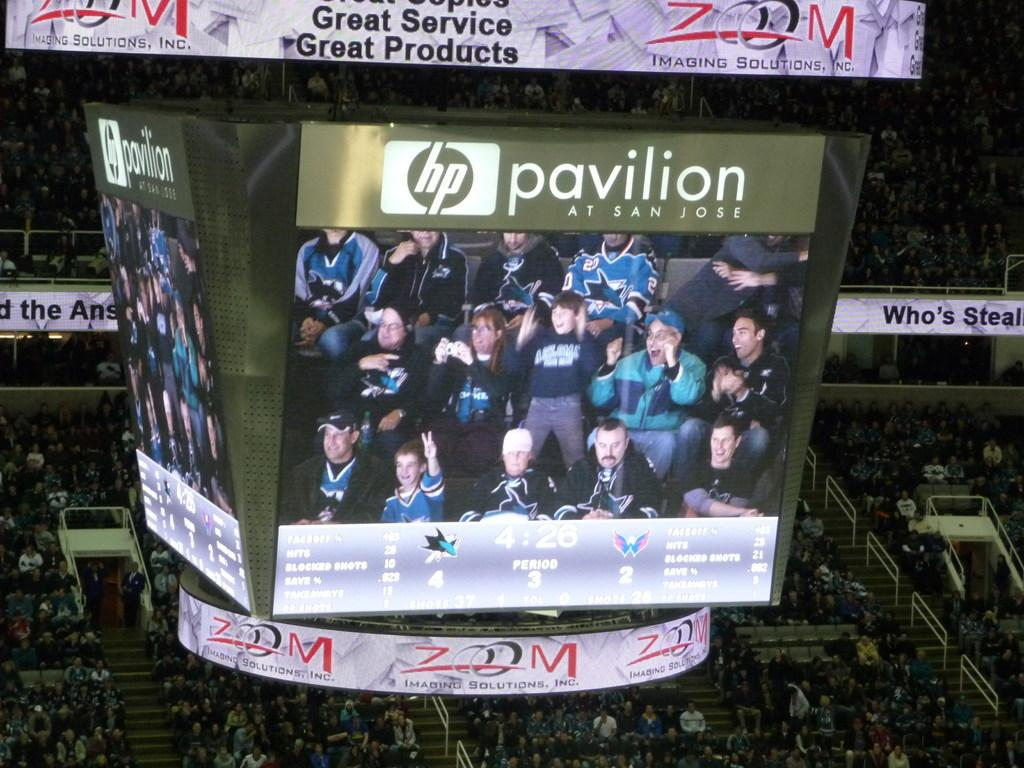Provide a one-sentence caption for the provided image. A megatron above an arena that says it's the hp pavilion at San Jose. 